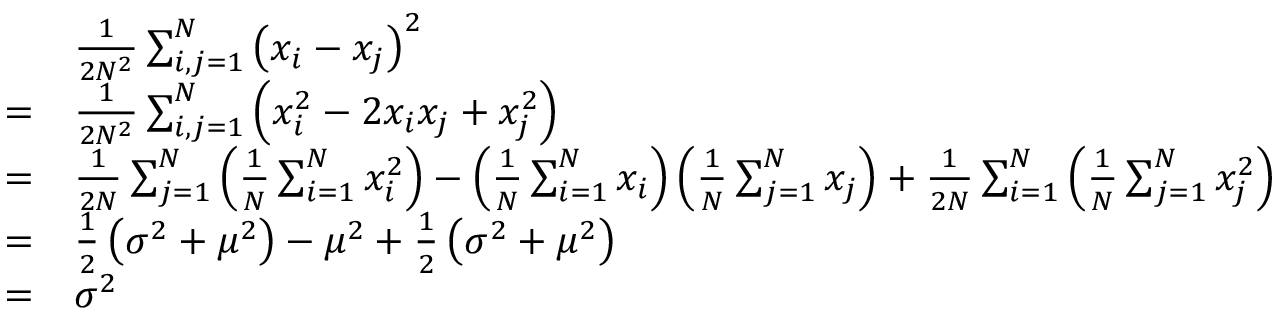Convert formula to latex. <formula><loc_0><loc_0><loc_500><loc_500>{ \begin{array} { r l } & { { \frac { 1 } { 2 N ^ { 2 } } } \sum _ { i , j = 1 } ^ { N } \left ( x _ { i } - x _ { j } \right ) ^ { 2 } } \\ { = } & { { \frac { 1 } { 2 N ^ { 2 } } } \sum _ { i , j = 1 } ^ { N } \left ( x _ { i } ^ { 2 } - 2 x _ { i } x _ { j } + x _ { j } ^ { 2 } \right ) } \\ { = } & { { \frac { 1 } { 2 N } } \sum _ { j = 1 } ^ { N } \left ( { \frac { 1 } { N } } \sum _ { i = 1 } ^ { N } x _ { i } ^ { 2 } \right ) - \left ( { \frac { 1 } { N } } \sum _ { i = 1 } ^ { N } x _ { i } \right ) \left ( { \frac { 1 } { N } } \sum _ { j = 1 } ^ { N } x _ { j } \right ) + { \frac { 1 } { 2 N } } \sum _ { i = 1 } ^ { N } \left ( { \frac { 1 } { N } } \sum _ { j = 1 } ^ { N } x _ { j } ^ { 2 } \right ) } \\ { = } & { { \frac { 1 } { 2 } } \left ( \sigma ^ { 2 } + \mu ^ { 2 } \right ) - \mu ^ { 2 } + { \frac { 1 } { 2 } } \left ( \sigma ^ { 2 } + \mu ^ { 2 } \right ) } \\ { = } & { \sigma ^ { 2 } } \end{array} }</formula> 